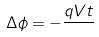Convert formula to latex. <formula><loc_0><loc_0><loc_500><loc_500>\Delta \phi = - \frac { q V t } { }</formula> 